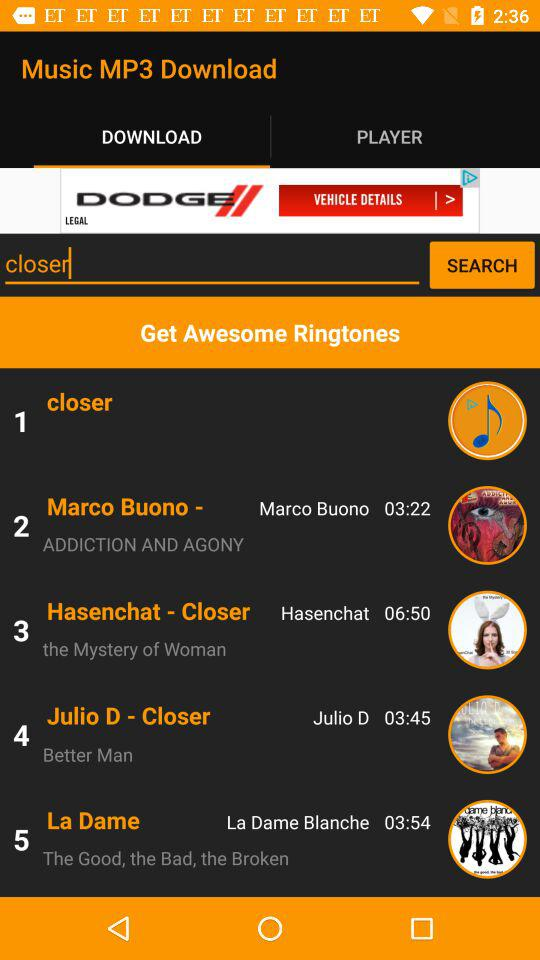Who is the singer of the song "ADDICTION AND AGONY"? The singer is Marco Buono. 